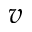<formula> <loc_0><loc_0><loc_500><loc_500>v</formula> 